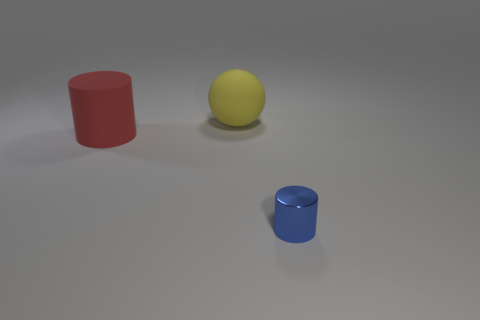Add 2 large purple metal objects. How many objects exist? 5 Subtract all balls. How many objects are left? 2 Subtract 1 cylinders. How many cylinders are left? 1 Subtract all yellow cylinders. Subtract all purple spheres. How many cylinders are left? 2 Subtract all gray spheres. How many blue cylinders are left? 1 Subtract all blue metal objects. Subtract all large cylinders. How many objects are left? 1 Add 2 tiny blue shiny cylinders. How many tiny blue shiny cylinders are left? 3 Add 2 large green rubber cylinders. How many large green rubber cylinders exist? 2 Subtract all red cylinders. How many cylinders are left? 1 Subtract 0 blue spheres. How many objects are left? 3 